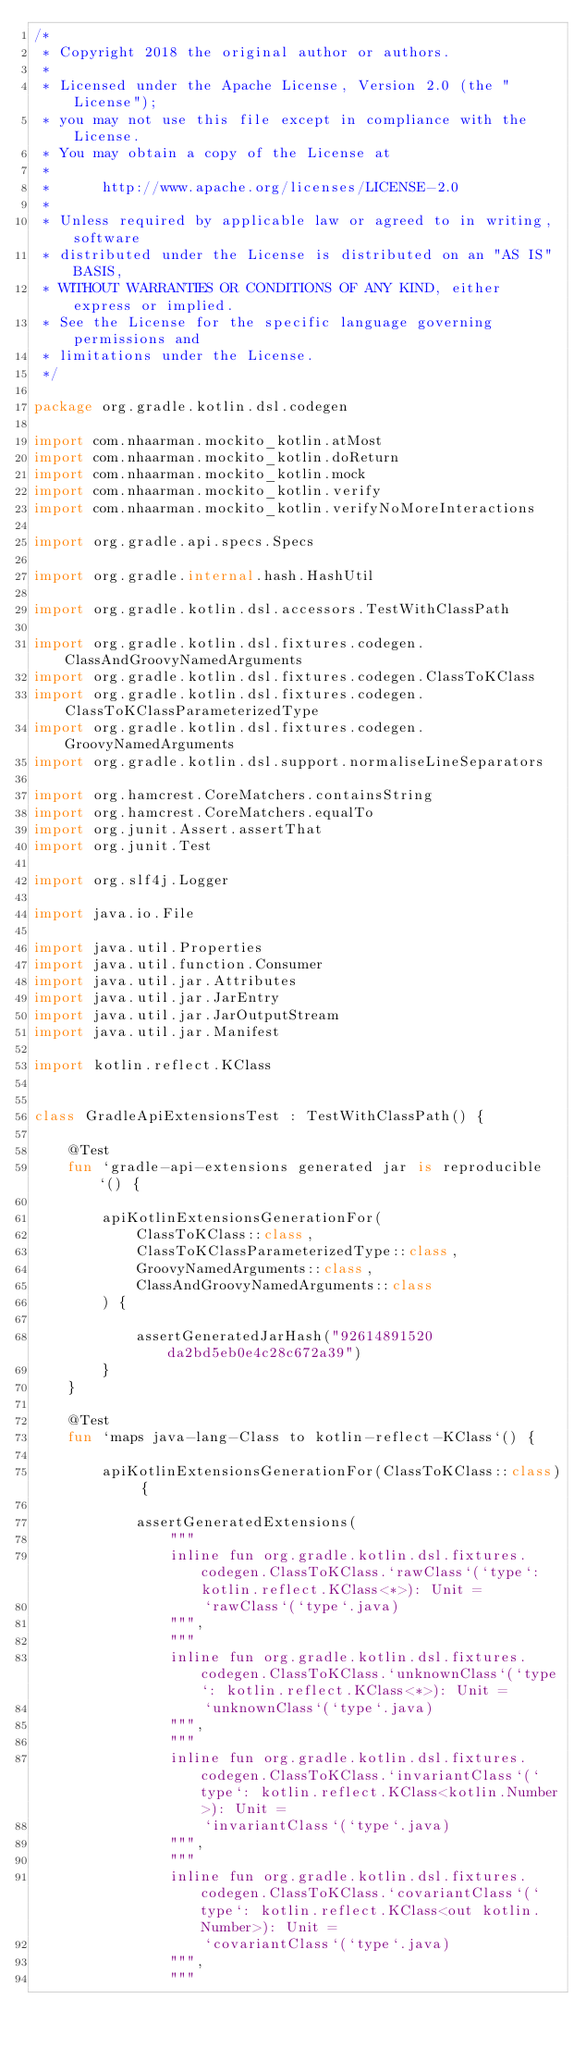<code> <loc_0><loc_0><loc_500><loc_500><_Kotlin_>/*
 * Copyright 2018 the original author or authors.
 *
 * Licensed under the Apache License, Version 2.0 (the "License");
 * you may not use this file except in compliance with the License.
 * You may obtain a copy of the License at
 *
 *      http://www.apache.org/licenses/LICENSE-2.0
 *
 * Unless required by applicable law or agreed to in writing, software
 * distributed under the License is distributed on an "AS IS" BASIS,
 * WITHOUT WARRANTIES OR CONDITIONS OF ANY KIND, either express or implied.
 * See the License for the specific language governing permissions and
 * limitations under the License.
 */

package org.gradle.kotlin.dsl.codegen

import com.nhaarman.mockito_kotlin.atMost
import com.nhaarman.mockito_kotlin.doReturn
import com.nhaarman.mockito_kotlin.mock
import com.nhaarman.mockito_kotlin.verify
import com.nhaarman.mockito_kotlin.verifyNoMoreInteractions

import org.gradle.api.specs.Specs

import org.gradle.internal.hash.HashUtil

import org.gradle.kotlin.dsl.accessors.TestWithClassPath

import org.gradle.kotlin.dsl.fixtures.codegen.ClassAndGroovyNamedArguments
import org.gradle.kotlin.dsl.fixtures.codegen.ClassToKClass
import org.gradle.kotlin.dsl.fixtures.codegen.ClassToKClassParameterizedType
import org.gradle.kotlin.dsl.fixtures.codegen.GroovyNamedArguments
import org.gradle.kotlin.dsl.support.normaliseLineSeparators

import org.hamcrest.CoreMatchers.containsString
import org.hamcrest.CoreMatchers.equalTo
import org.junit.Assert.assertThat
import org.junit.Test

import org.slf4j.Logger

import java.io.File

import java.util.Properties
import java.util.function.Consumer
import java.util.jar.Attributes
import java.util.jar.JarEntry
import java.util.jar.JarOutputStream
import java.util.jar.Manifest

import kotlin.reflect.KClass


class GradleApiExtensionsTest : TestWithClassPath() {

    @Test
    fun `gradle-api-extensions generated jar is reproducible`() {

        apiKotlinExtensionsGenerationFor(
            ClassToKClass::class,
            ClassToKClassParameterizedType::class,
            GroovyNamedArguments::class,
            ClassAndGroovyNamedArguments::class
        ) {

            assertGeneratedJarHash("92614891520da2bd5eb0e4c28c672a39")
        }
    }

    @Test
    fun `maps java-lang-Class to kotlin-reflect-KClass`() {

        apiKotlinExtensionsGenerationFor(ClassToKClass::class) {

            assertGeneratedExtensions(
                """
                inline fun org.gradle.kotlin.dsl.fixtures.codegen.ClassToKClass.`rawClass`(`type`: kotlin.reflect.KClass<*>): Unit =
                    `rawClass`(`type`.java)
                """,
                """
                inline fun org.gradle.kotlin.dsl.fixtures.codegen.ClassToKClass.`unknownClass`(`type`: kotlin.reflect.KClass<*>): Unit =
                    `unknownClass`(`type`.java)
                """,
                """
                inline fun org.gradle.kotlin.dsl.fixtures.codegen.ClassToKClass.`invariantClass`(`type`: kotlin.reflect.KClass<kotlin.Number>): Unit =
                    `invariantClass`(`type`.java)
                """,
                """
                inline fun org.gradle.kotlin.dsl.fixtures.codegen.ClassToKClass.`covariantClass`(`type`: kotlin.reflect.KClass<out kotlin.Number>): Unit =
                    `covariantClass`(`type`.java)
                """,
                """</code> 